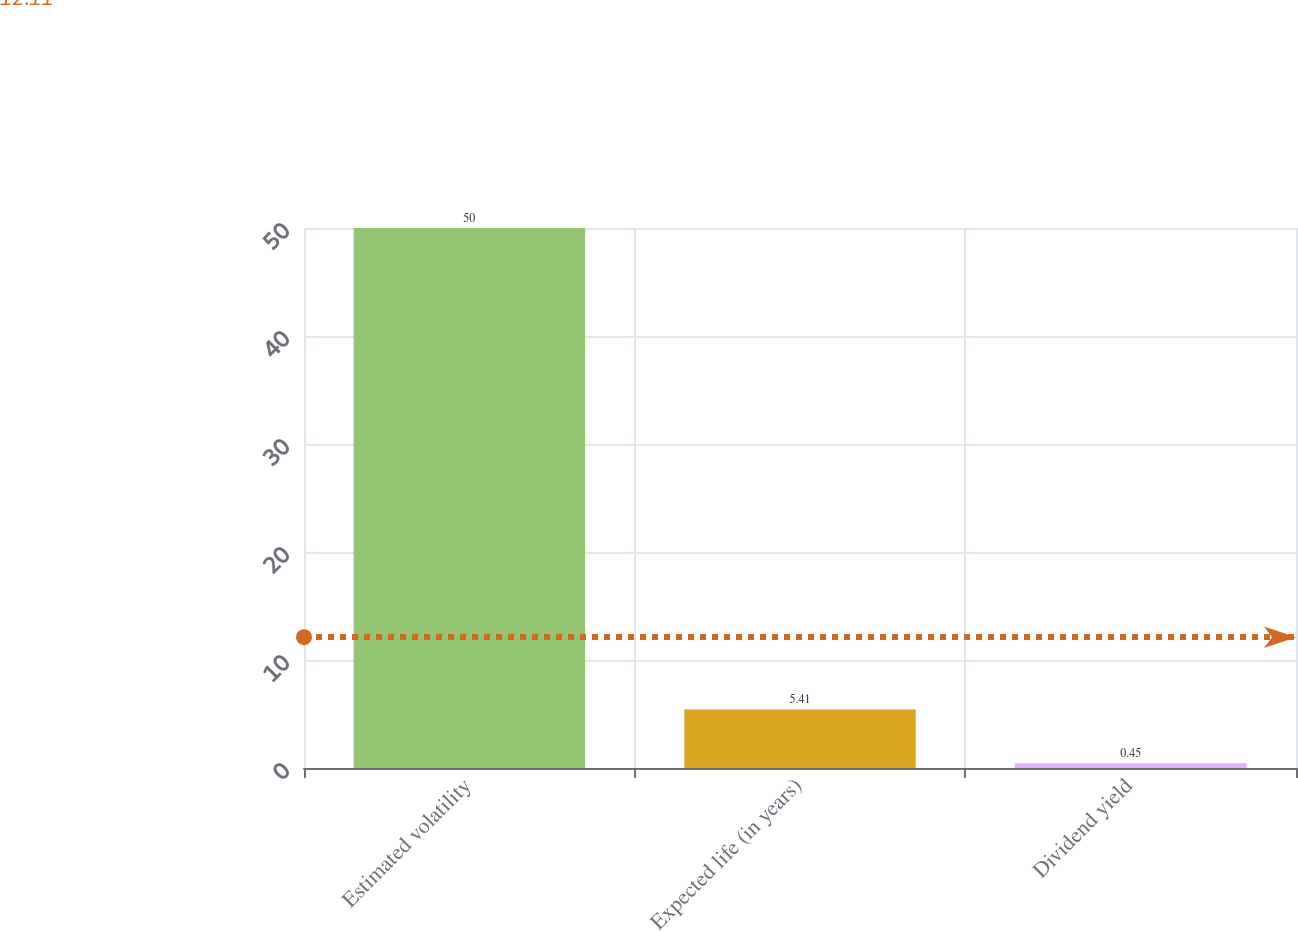<chart> <loc_0><loc_0><loc_500><loc_500><bar_chart><fcel>Estimated volatility<fcel>Expected life (in years)<fcel>Dividend yield<nl><fcel>50<fcel>5.41<fcel>0.45<nl></chart> 